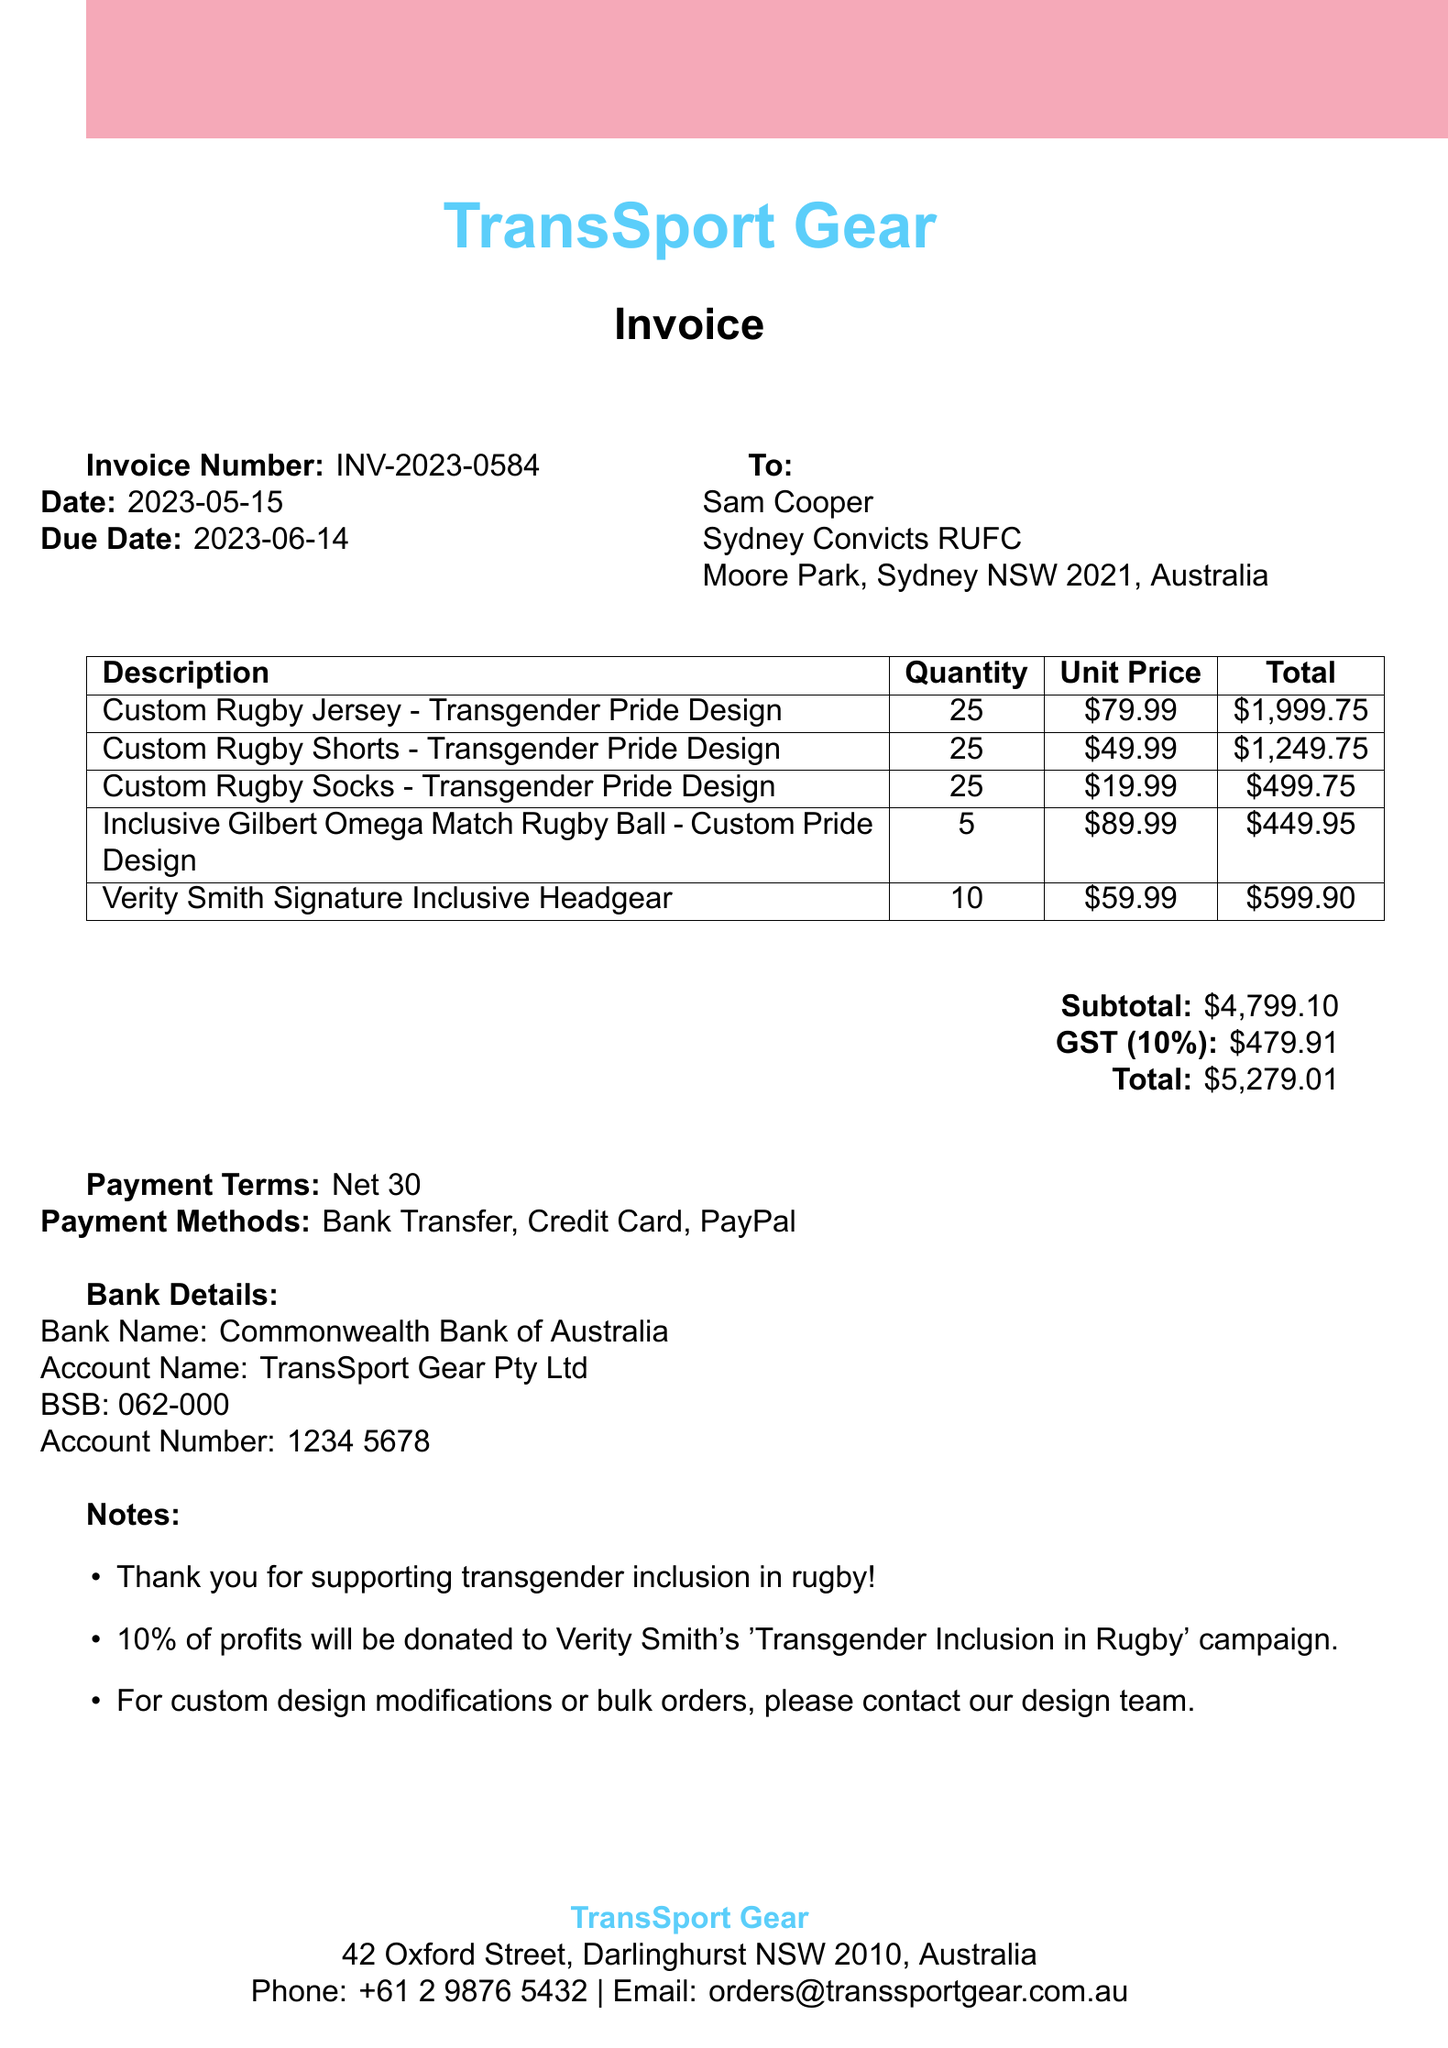What is the invoice number? The invoice number is provided in the document and is identified as INV-2023-0584.
Answer: INV-2023-0584 What is the total amount due? The total amount due is calculated based on the subtotal, GST, and any additional charges. The total provided is $5,279.01.
Answer: $5,279.01 Who is the customer? The document lists the customer information, with the name being Sam Cooper.
Answer: Sam Cooper How many rugby jerseys were ordered? The order details include quantities for each item, with 25 custom rugby jerseys ordered.
Answer: 25 What is the payment term specified? The payment terms are outlined in the document and specified as Net 30.
Answer: Net 30 How much GST is included in the total? The GST amount is a specific calculation listed in the document, which is $479.91.
Answer: $479.91 What is the supplier's email address? The supplier's contact information includes an email address, which is orders@transsportgear.com.au.
Answer: orders@transsportgear.com.au What is included in the notes section? The notes section contains multiple important points, including support for transgender inclusion in rugby and a donation to Verity Smith's campaign.
Answer: 10% of profits will be donated to Verity Smith's 'Transgender Inclusion in Rugby' campaign What type of items were ordered? The items ordered are customized sporting gear reflecting a theme of inclusion, specifically transgender pride designs.
Answer: Custom Rugby Gear 